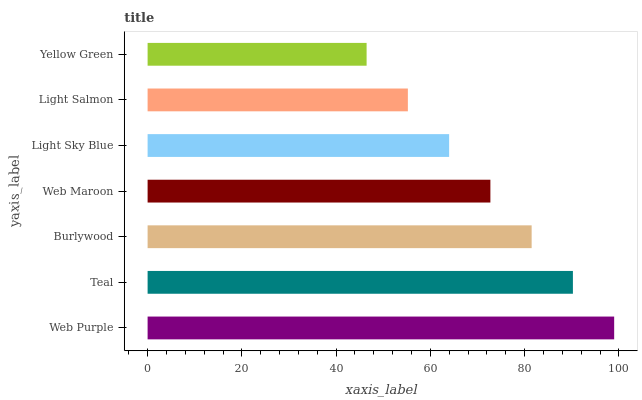Is Yellow Green the minimum?
Answer yes or no. Yes. Is Web Purple the maximum?
Answer yes or no. Yes. Is Teal the minimum?
Answer yes or no. No. Is Teal the maximum?
Answer yes or no. No. Is Web Purple greater than Teal?
Answer yes or no. Yes. Is Teal less than Web Purple?
Answer yes or no. Yes. Is Teal greater than Web Purple?
Answer yes or no. No. Is Web Purple less than Teal?
Answer yes or no. No. Is Web Maroon the high median?
Answer yes or no. Yes. Is Web Maroon the low median?
Answer yes or no. Yes. Is Light Salmon the high median?
Answer yes or no. No. Is Web Purple the low median?
Answer yes or no. No. 